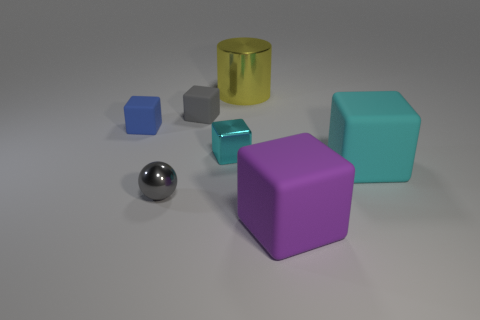Subtract all gray cylinders. How many cyan cubes are left? 2 Add 2 large rubber things. How many objects exist? 9 Subtract all large cyan matte blocks. How many blocks are left? 4 Subtract 3 cubes. How many cubes are left? 2 Subtract all gray blocks. How many blocks are left? 4 Subtract all cubes. How many objects are left? 2 Subtract all red cubes. Subtract all blue balls. How many cubes are left? 5 Subtract all tiny metallic spheres. Subtract all metal cubes. How many objects are left? 5 Add 4 yellow objects. How many yellow objects are left? 5 Add 5 small gray metal cubes. How many small gray metal cubes exist? 5 